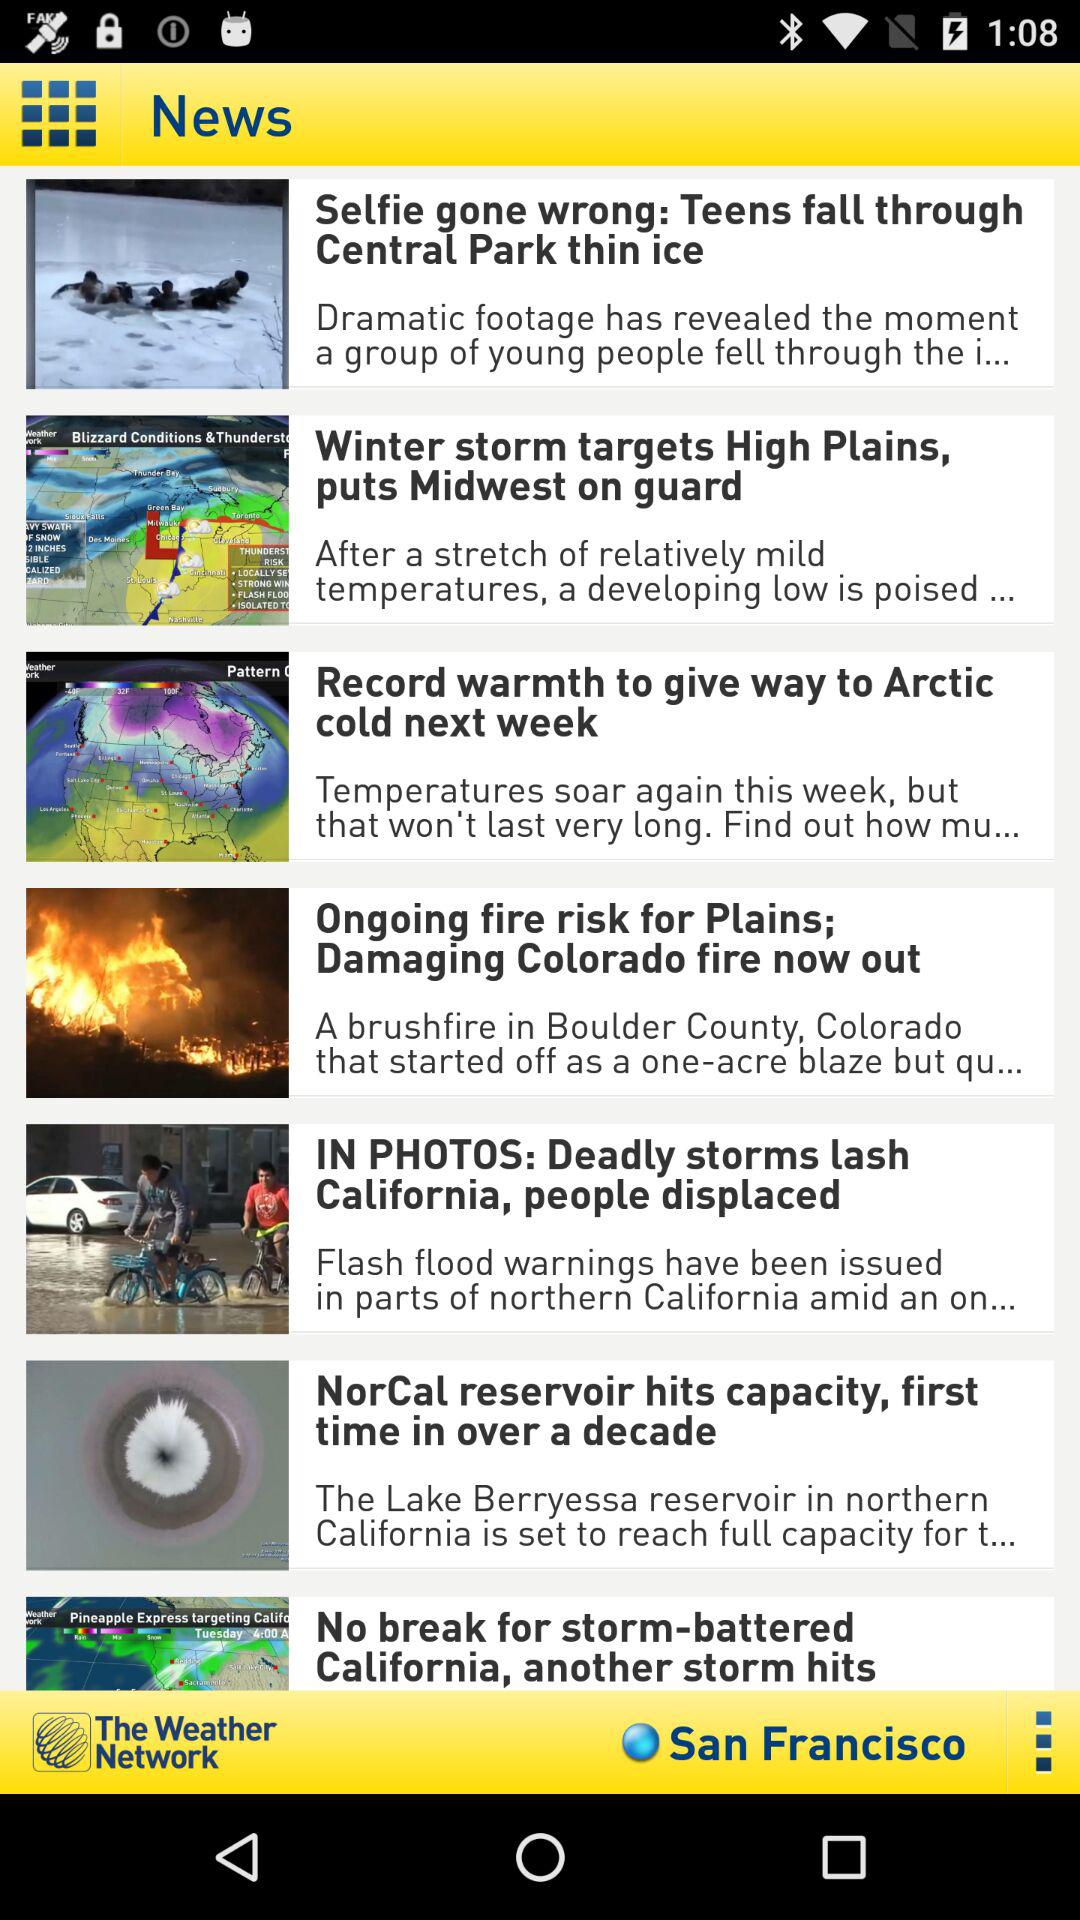What is the mentioned location? The mentioned location is San Francisco. 